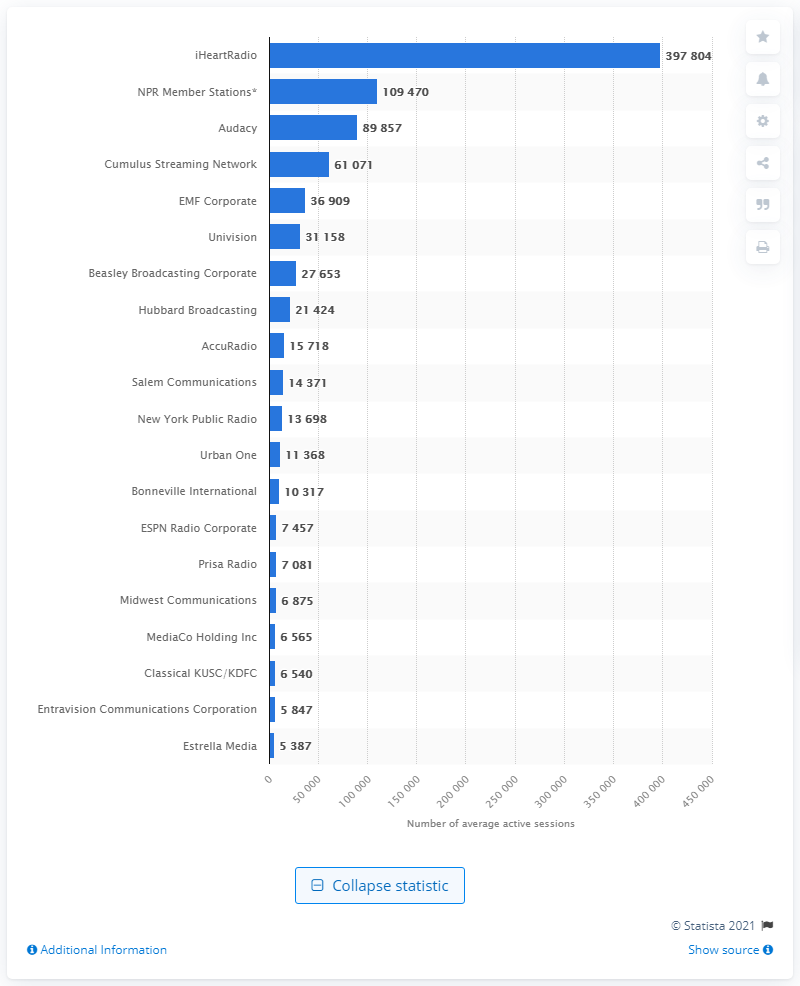Point out several critical features in this image. In March 2021, iHeartRadio was the leading online radio company in the United States. 